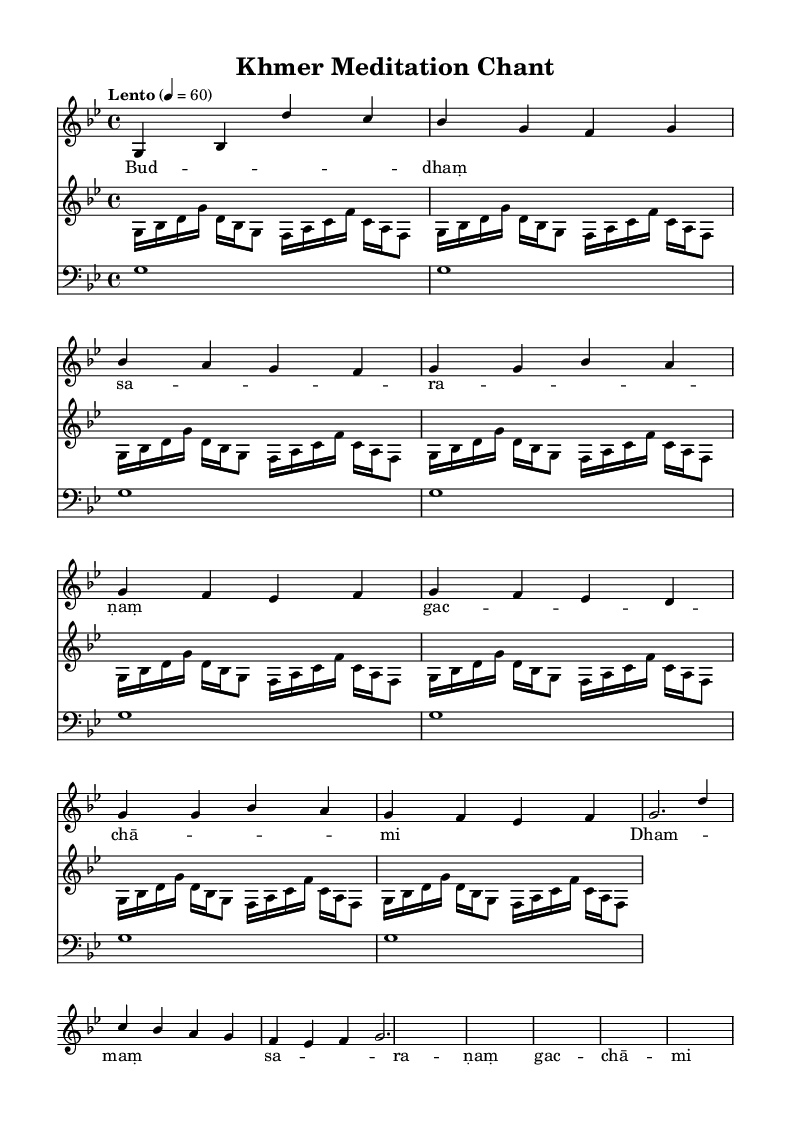What is the key signature of this music? The key signature is G minor, which has two flats (B♭ and E♭) indicated at the beginning of the staff.
Answer: G minor What is the time signature of this music? The time signature is 4/4, which is shown at the beginning of the score and indicates four beats per measure.
Answer: 4/4 What is the tempo marking of this music? The tempo marking is "Lento," and the Italian term suggests a slow tempo, specifically quarter note equals 60 beats per minute, indicated in the score.
Answer: Lento How many measures are in the verse section? The verse section consists of two measures, as noted in the part where the lyrics are associated with the melody in the voice section.
Answer: 2 measures What is the primary function of the singing bowl in this piece? The singing bowl's primary function is to provide sustained pitches, indicated by whole notes on the first beat of each measure, contributing to an ambient atmosphere suitable for meditation.
Answer: Sustained pitches Which phrases in the lyrics repeat in the chant? The phrases "Bud -- dhaṃ sa -- ra -- ṇaṃ gac -- chā -- mi" and "Dham -- maṃ sa -- ra -- ṇaṃ gac -- chā -- mi" repeat, forming a meditative structure and enhancing the chant's spiritual aspect.
Answer: Repeat phrases What type of instrument is represented by "roneatEk" in the score? "RoneatEk" represents a traditional Khmer xylophone, and it plays a simplified accompaniment to complement the vocal melody in the piece.
Answer: Traditional Khmer xylophone 